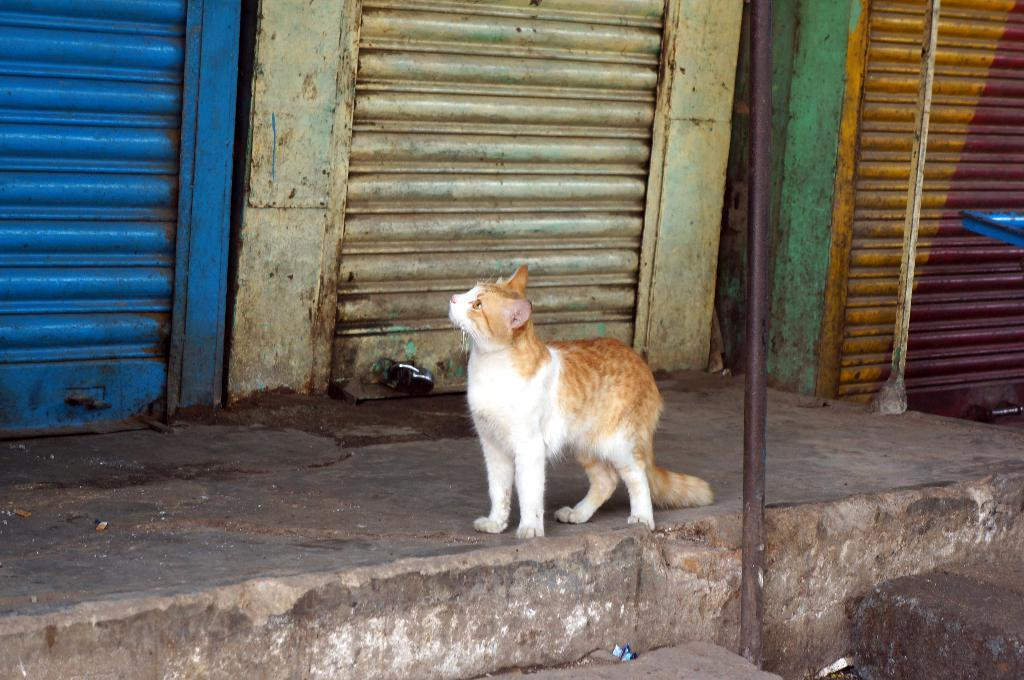What type of animal is in the image? There is a cat in the image. What type of window covering is visible in the image? There are shutters in the image. What type of security feature is present in the image? There is a lock in the image. What type of support structure is visible in the image? There are poles in the image. What type of brain can be seen in the image? There is no brain present in the image. What type of dad is visible in the image? There is no dad present in the image. 